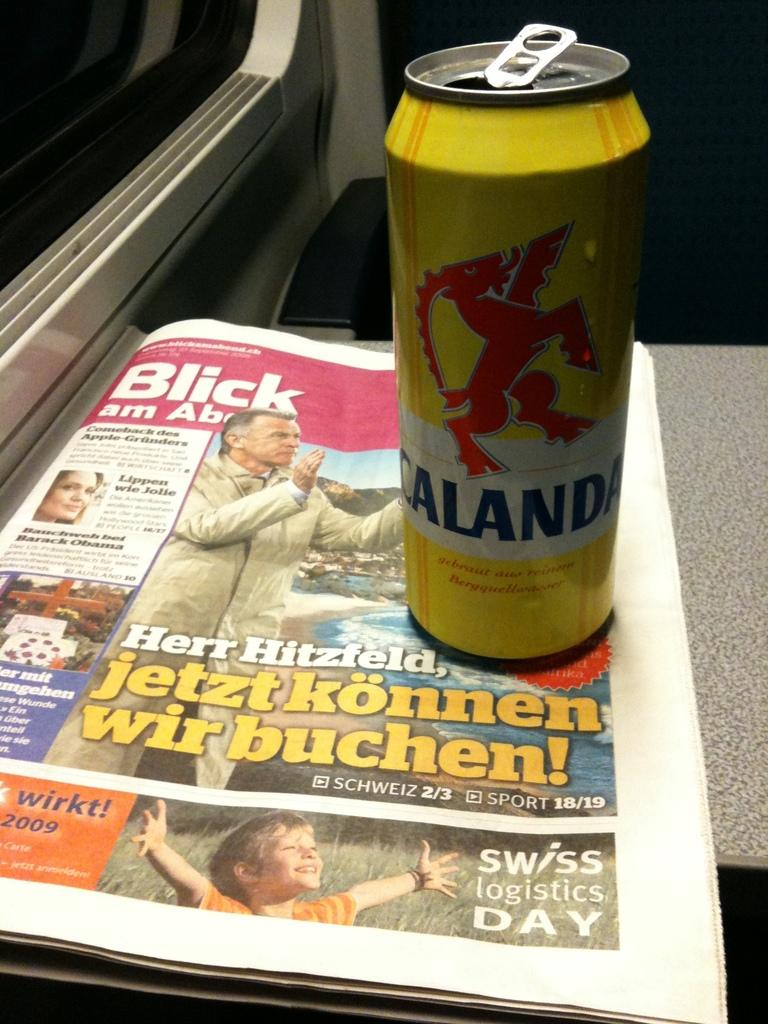<image>
Summarize the visual content of the image. A yellow can of beer on a copy of a news paper that says swiss logistics Day. 